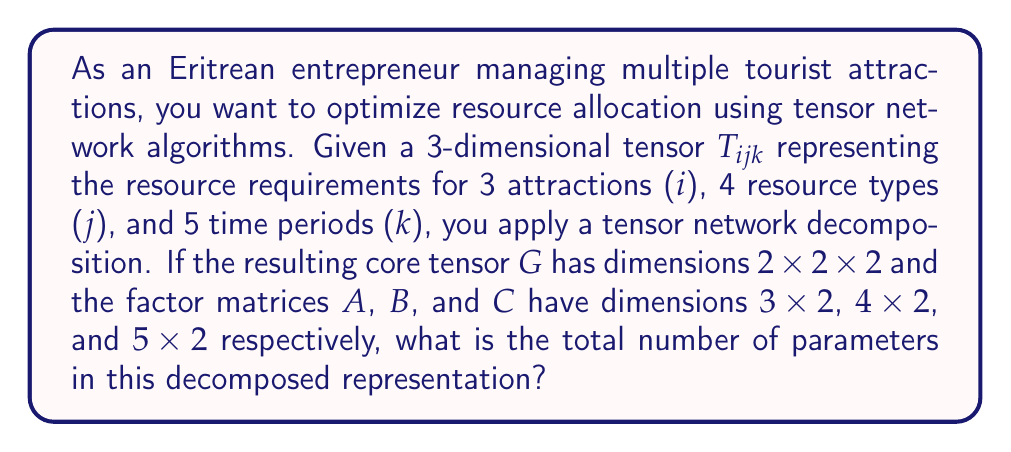Can you solve this math problem? Let's break this down step-by-step:

1) The original tensor $T_{ijk}$ has dimensions 3x4x5, which means it has $3 \times 4 \times 5 = 60$ elements.

2) After decomposition, we have:
   - Core tensor $G$ with dimensions 2x2x2
   - Factor matrix $A$ with dimensions 3x2
   - Factor matrix $B$ with dimensions 4x2
   - Factor matrix $C$ with dimensions 5x2

3) Let's count the parameters in each component:
   - $G$: $2 \times 2 \times 2 = 8$ elements
   - $A$: $3 \times 2 = 6$ elements
   - $B$: $4 \times 2 = 8$ elements
   - $C$: $5 \times 2 = 10$ elements

4) The total number of parameters in the decomposed representation is the sum of all these elements:

   $$ \text{Total parameters} = 8 + 6 + 8 + 10 = 32 $$

5) This decomposed representation (32 parameters) is more compact than the original tensor (60 elements), allowing for more efficient resource allocation calculations while preserving the essential structure of the data.
Answer: 32 parameters 